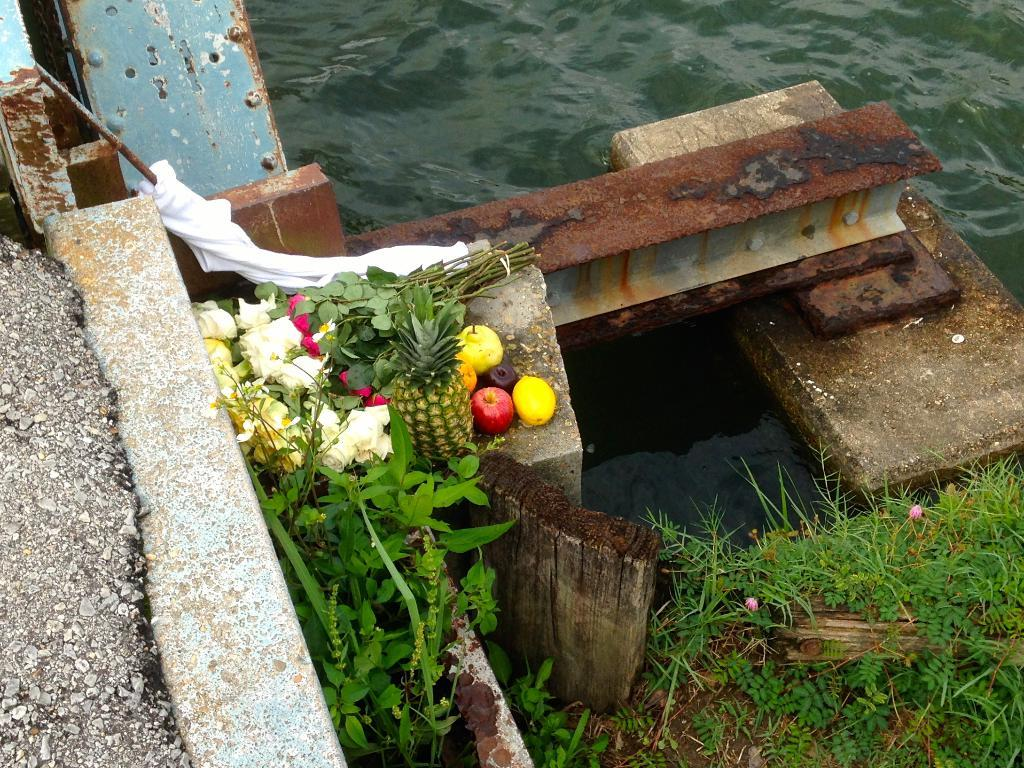What natural element is visible in the image? Water is visible in the image. What type of food items can be seen in the image? There are fruits in the image. What type of flora is present in the image? There are flowers and plants in the image. What type of vegetation is visible in the image? There is grass in the image. What type of soup is being served in the image? There is no soup present in the image. What type of reading material is visible in the image? There is no reading material present in the image. 